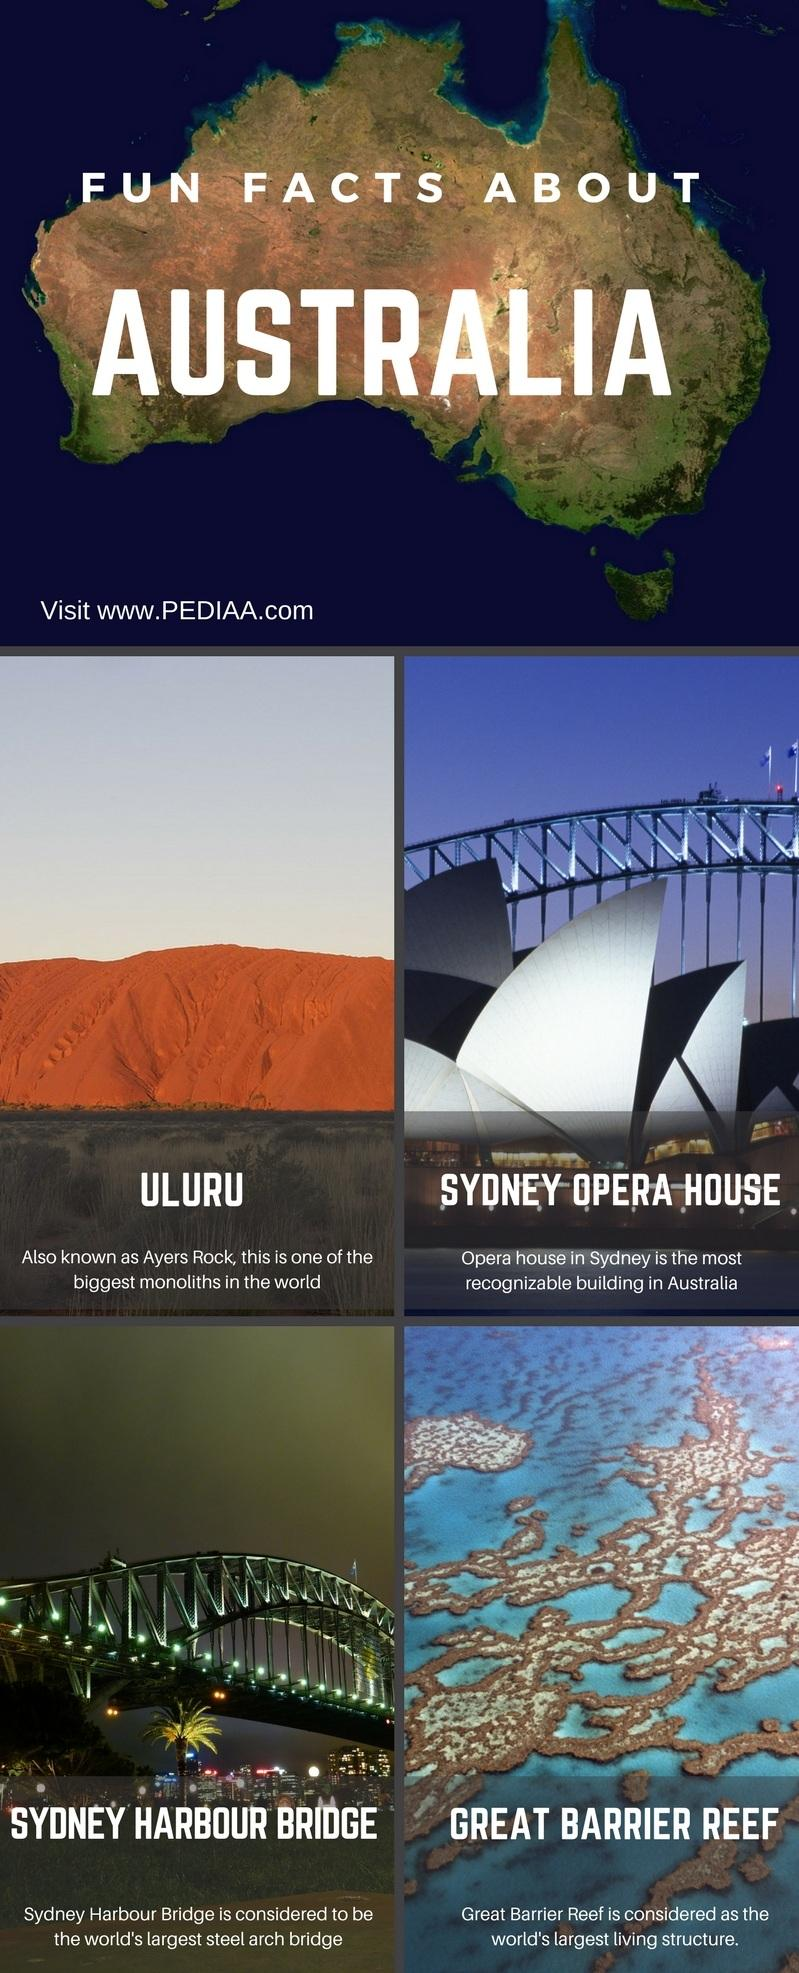Point out several critical features in this image. Ayers Rock is also known as Uluru. This infographic contains four facts about Australia. 